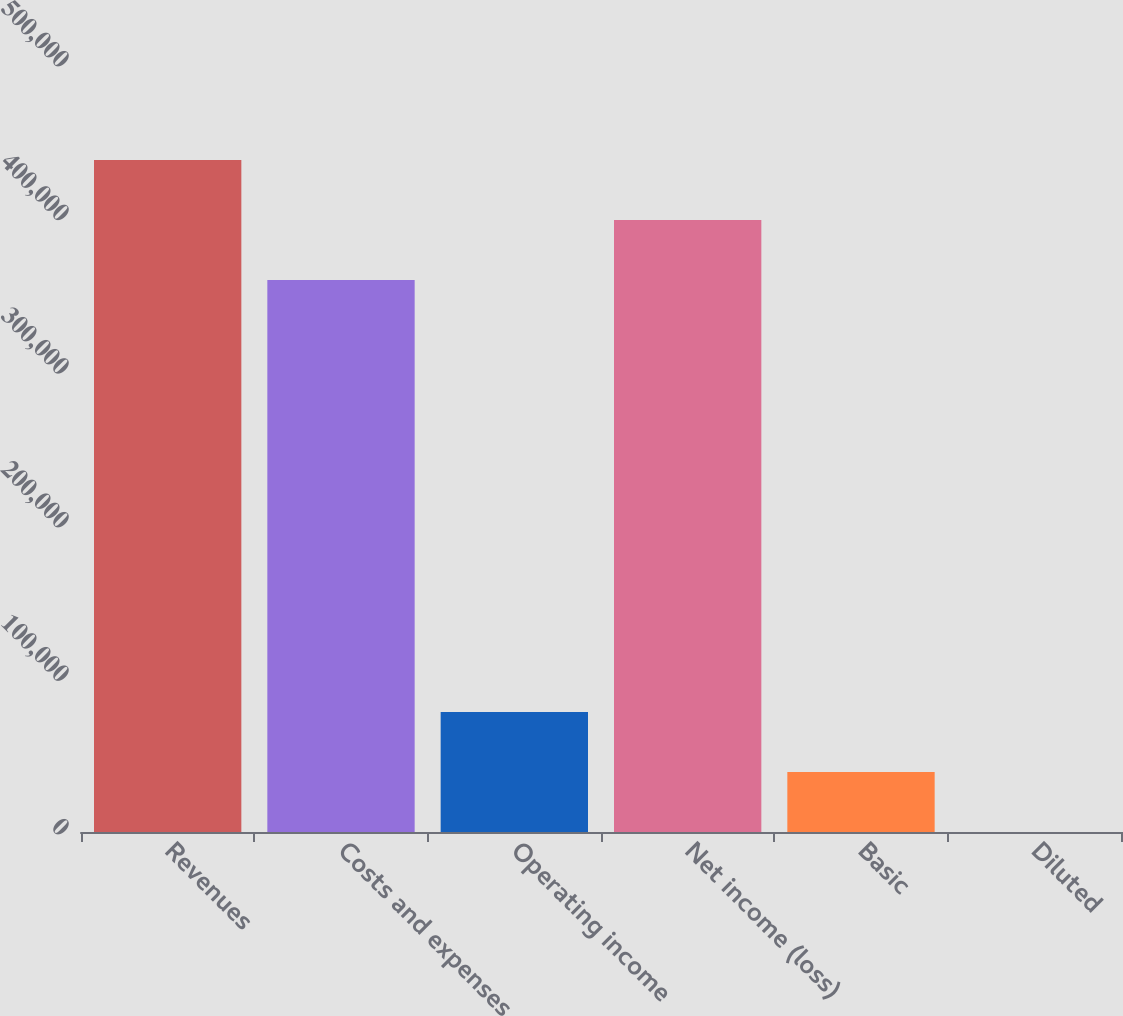<chart> <loc_0><loc_0><loc_500><loc_500><bar_chart><fcel>Revenues<fcel>Costs and expenses<fcel>Operating income<fcel>Net income (loss)<fcel>Basic<fcel>Diluted<nl><fcel>437573<fcel>359435<fcel>78139.2<fcel>398504<fcel>39070.4<fcel>1.52<nl></chart> 